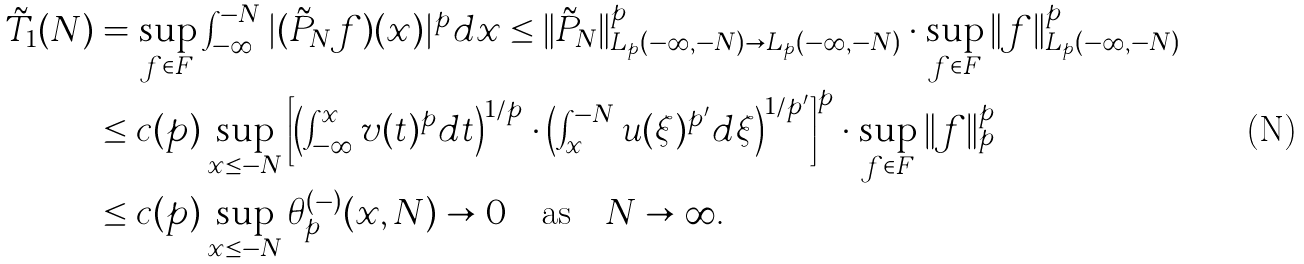Convert formula to latex. <formula><loc_0><loc_0><loc_500><loc_500>\tilde { T } _ { 1 } ( N ) & = \sup _ { f \in F } \int _ { - \infty } ^ { - N } | ( \tilde { P } _ { N } f ) ( x ) | ^ { p } d x \leq \| \tilde { P } _ { N } \| ^ { p } _ { L _ { p } ( - \infty , - N ) \to L _ { p } ( - \infty , - N ) } \cdot \sup _ { f \in F } \| f \| _ { L _ { p } ( - \infty , - N ) } ^ { p } \\ & \leq c ( p ) \sup _ { x \leq - N } \left [ \left ( \int _ { - \infty } ^ { x } v ( t ) ^ { p } d t \right ) ^ { 1 / p } \cdot \left ( \int _ { x } ^ { - N } u ( \xi ) ^ { p ^ { \prime } } d \xi \right ) ^ { 1 / p ^ { \prime } } \right ] ^ { p } \cdot \sup _ { f \in F } \| f \| _ { p } ^ { p } \\ & \leq c ( p ) \sup _ { x \leq - N } \theta _ { p } ^ { ( - ) } ( x , N ) \to 0 \quad \text {as} \quad N \to \infty .</formula> 